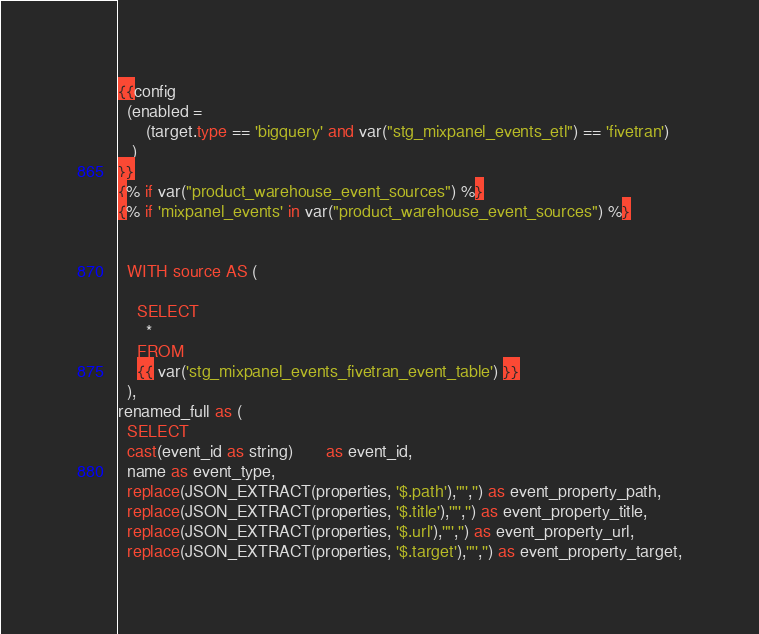<code> <loc_0><loc_0><loc_500><loc_500><_SQL_>{{config
  (enabled =
      (target.type == 'bigquery' and var("stg_mixpanel_events_etl") == 'fivetran')
   )
}}
{% if var("product_warehouse_event_sources") %}
{% if 'mixpanel_events' in var("product_warehouse_event_sources") %}


  WITH source AS (

    SELECT
      *
    FROM
    {{ var('stg_mixpanel_events_fivetran_event_table') }}
  ),
renamed_full as (
  SELECT
  cast(event_id as string)       as event_id,
  name as event_type,
  replace(JSON_EXTRACT(properties, '$.path'),'"','') as event_property_path,
  replace(JSON_EXTRACT(properties, '$.title'),'"','') as event_property_title,
  replace(JSON_EXTRACT(properties, '$.url'),'"','') as event_property_url,
  replace(JSON_EXTRACT(properties, '$.target'),'"','') as event_property_target,</code> 